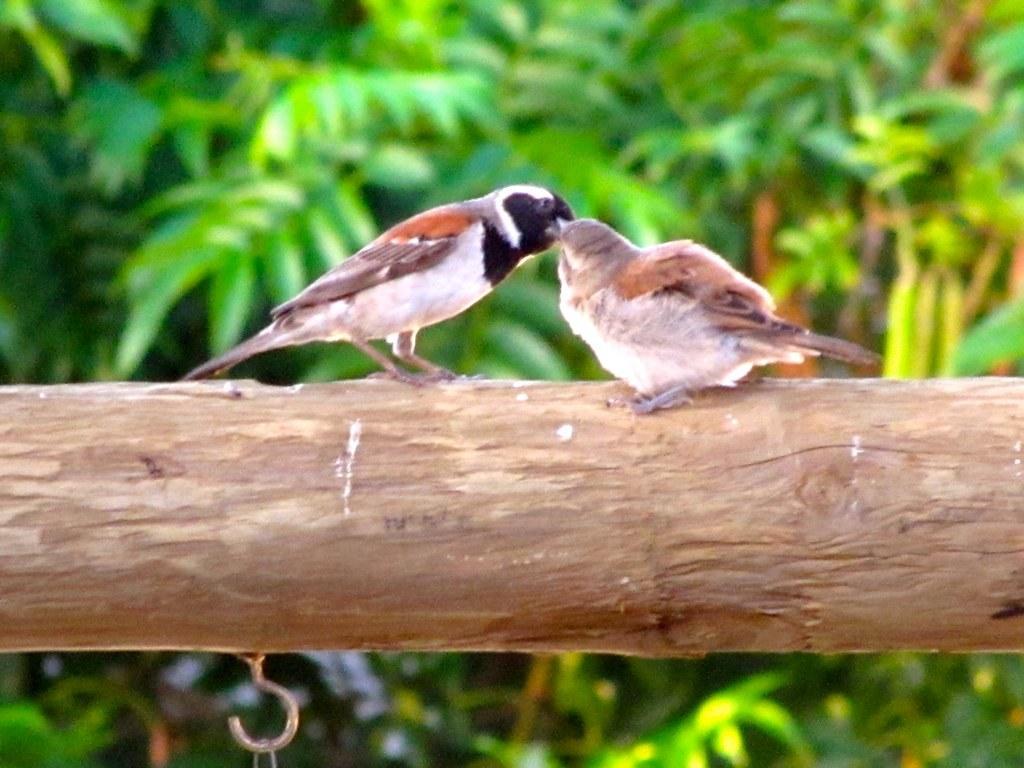Could you give a brief overview of what you see in this image? In this image we can see two sparrows which are standing on the branch and in the background of the image there are some leaves. 